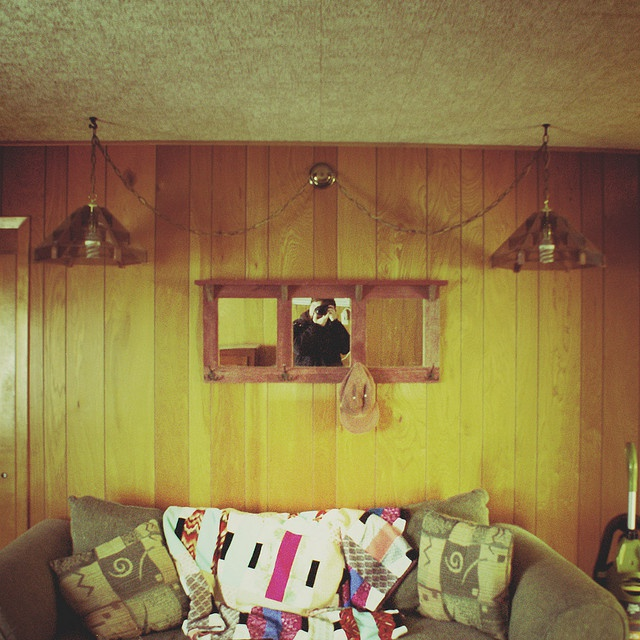Describe the objects in this image and their specific colors. I can see couch in gray, beige, and olive tones and people in gray, black, maroon, tan, and brown tones in this image. 